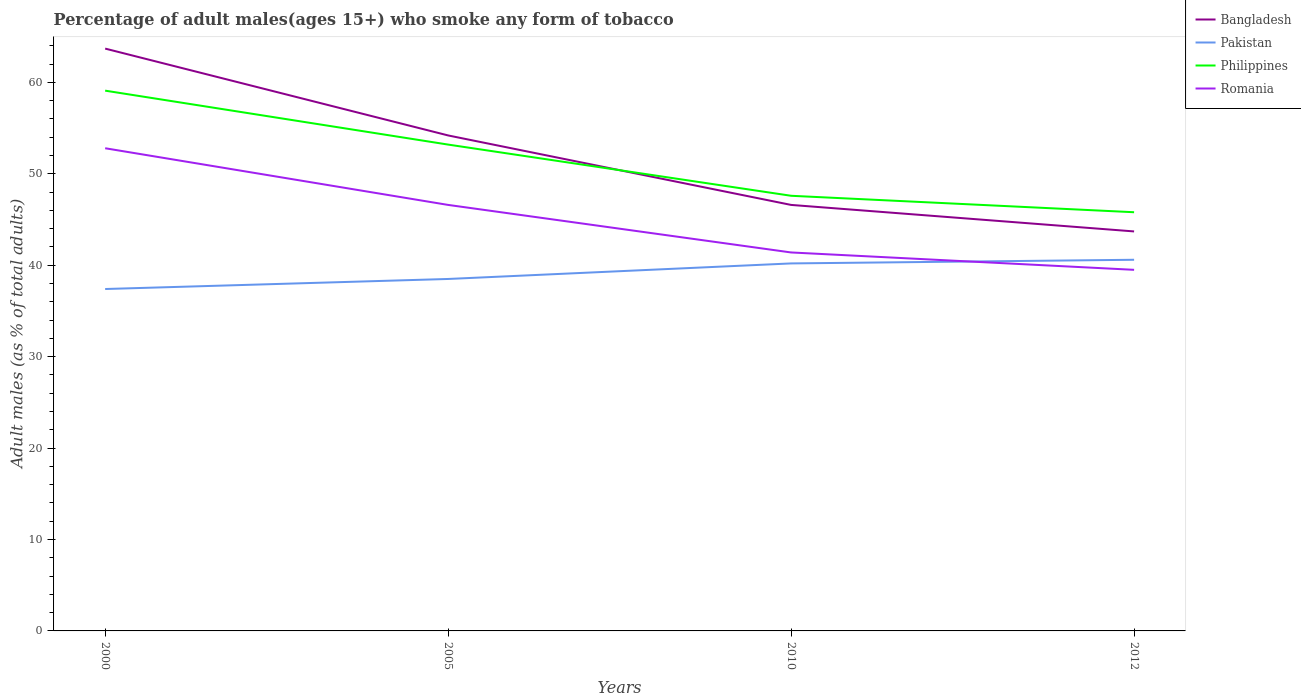Is the number of lines equal to the number of legend labels?
Your answer should be very brief. Yes. Across all years, what is the maximum percentage of adult males who smoke in Bangladesh?
Ensure brevity in your answer.  43.7. In which year was the percentage of adult males who smoke in Bangladesh maximum?
Your response must be concise. 2012. How many lines are there?
Your response must be concise. 4. What is the difference between two consecutive major ticks on the Y-axis?
Your answer should be compact. 10. Does the graph contain any zero values?
Your response must be concise. No. Does the graph contain grids?
Make the answer very short. No. How are the legend labels stacked?
Make the answer very short. Vertical. What is the title of the graph?
Make the answer very short. Percentage of adult males(ages 15+) who smoke any form of tobacco. Does "Chile" appear as one of the legend labels in the graph?
Offer a terse response. No. What is the label or title of the Y-axis?
Offer a terse response. Adult males (as % of total adults). What is the Adult males (as % of total adults) of Bangladesh in 2000?
Offer a very short reply. 63.7. What is the Adult males (as % of total adults) in Pakistan in 2000?
Give a very brief answer. 37.4. What is the Adult males (as % of total adults) in Philippines in 2000?
Your response must be concise. 59.1. What is the Adult males (as % of total adults) of Romania in 2000?
Your response must be concise. 52.8. What is the Adult males (as % of total adults) of Bangladesh in 2005?
Ensure brevity in your answer.  54.2. What is the Adult males (as % of total adults) in Pakistan in 2005?
Your response must be concise. 38.5. What is the Adult males (as % of total adults) of Philippines in 2005?
Provide a succinct answer. 53.2. What is the Adult males (as % of total adults) of Romania in 2005?
Your response must be concise. 46.6. What is the Adult males (as % of total adults) in Bangladesh in 2010?
Your response must be concise. 46.6. What is the Adult males (as % of total adults) in Pakistan in 2010?
Your response must be concise. 40.2. What is the Adult males (as % of total adults) in Philippines in 2010?
Your response must be concise. 47.6. What is the Adult males (as % of total adults) in Romania in 2010?
Provide a succinct answer. 41.4. What is the Adult males (as % of total adults) in Bangladesh in 2012?
Ensure brevity in your answer.  43.7. What is the Adult males (as % of total adults) of Pakistan in 2012?
Offer a very short reply. 40.6. What is the Adult males (as % of total adults) in Philippines in 2012?
Your answer should be compact. 45.8. What is the Adult males (as % of total adults) in Romania in 2012?
Your answer should be very brief. 39.5. Across all years, what is the maximum Adult males (as % of total adults) in Bangladesh?
Ensure brevity in your answer.  63.7. Across all years, what is the maximum Adult males (as % of total adults) of Pakistan?
Ensure brevity in your answer.  40.6. Across all years, what is the maximum Adult males (as % of total adults) in Philippines?
Ensure brevity in your answer.  59.1. Across all years, what is the maximum Adult males (as % of total adults) of Romania?
Your response must be concise. 52.8. Across all years, what is the minimum Adult males (as % of total adults) of Bangladesh?
Offer a very short reply. 43.7. Across all years, what is the minimum Adult males (as % of total adults) of Pakistan?
Your answer should be very brief. 37.4. Across all years, what is the minimum Adult males (as % of total adults) of Philippines?
Offer a very short reply. 45.8. Across all years, what is the minimum Adult males (as % of total adults) of Romania?
Give a very brief answer. 39.5. What is the total Adult males (as % of total adults) in Bangladesh in the graph?
Ensure brevity in your answer.  208.2. What is the total Adult males (as % of total adults) of Pakistan in the graph?
Ensure brevity in your answer.  156.7. What is the total Adult males (as % of total adults) in Philippines in the graph?
Your response must be concise. 205.7. What is the total Adult males (as % of total adults) of Romania in the graph?
Make the answer very short. 180.3. What is the difference between the Adult males (as % of total adults) of Pakistan in 2000 and that in 2005?
Your answer should be compact. -1.1. What is the difference between the Adult males (as % of total adults) of Philippines in 2000 and that in 2005?
Provide a short and direct response. 5.9. What is the difference between the Adult males (as % of total adults) of Romania in 2000 and that in 2005?
Make the answer very short. 6.2. What is the difference between the Adult males (as % of total adults) of Bangladesh in 2000 and that in 2010?
Provide a succinct answer. 17.1. What is the difference between the Adult males (as % of total adults) of Romania in 2000 and that in 2010?
Your answer should be very brief. 11.4. What is the difference between the Adult males (as % of total adults) in Bangladesh in 2000 and that in 2012?
Offer a terse response. 20. What is the difference between the Adult males (as % of total adults) in Pakistan in 2000 and that in 2012?
Provide a succinct answer. -3.2. What is the difference between the Adult males (as % of total adults) in Philippines in 2000 and that in 2012?
Ensure brevity in your answer.  13.3. What is the difference between the Adult males (as % of total adults) of Pakistan in 2005 and that in 2010?
Offer a very short reply. -1.7. What is the difference between the Adult males (as % of total adults) in Philippines in 2005 and that in 2010?
Offer a terse response. 5.6. What is the difference between the Adult males (as % of total adults) of Romania in 2005 and that in 2010?
Offer a very short reply. 5.2. What is the difference between the Adult males (as % of total adults) of Bangladesh in 2005 and that in 2012?
Keep it short and to the point. 10.5. What is the difference between the Adult males (as % of total adults) of Pakistan in 2005 and that in 2012?
Your response must be concise. -2.1. What is the difference between the Adult males (as % of total adults) in Pakistan in 2010 and that in 2012?
Your response must be concise. -0.4. What is the difference between the Adult males (as % of total adults) in Romania in 2010 and that in 2012?
Keep it short and to the point. 1.9. What is the difference between the Adult males (as % of total adults) of Bangladesh in 2000 and the Adult males (as % of total adults) of Pakistan in 2005?
Offer a very short reply. 25.2. What is the difference between the Adult males (as % of total adults) in Pakistan in 2000 and the Adult males (as % of total adults) in Philippines in 2005?
Keep it short and to the point. -15.8. What is the difference between the Adult males (as % of total adults) of Pakistan in 2000 and the Adult males (as % of total adults) of Romania in 2005?
Keep it short and to the point. -9.2. What is the difference between the Adult males (as % of total adults) of Bangladesh in 2000 and the Adult males (as % of total adults) of Romania in 2010?
Keep it short and to the point. 22.3. What is the difference between the Adult males (as % of total adults) in Pakistan in 2000 and the Adult males (as % of total adults) in Philippines in 2010?
Your response must be concise. -10.2. What is the difference between the Adult males (as % of total adults) of Bangladesh in 2000 and the Adult males (as % of total adults) of Pakistan in 2012?
Offer a very short reply. 23.1. What is the difference between the Adult males (as % of total adults) in Bangladesh in 2000 and the Adult males (as % of total adults) in Romania in 2012?
Make the answer very short. 24.2. What is the difference between the Adult males (as % of total adults) of Pakistan in 2000 and the Adult males (as % of total adults) of Philippines in 2012?
Provide a short and direct response. -8.4. What is the difference between the Adult males (as % of total adults) in Philippines in 2000 and the Adult males (as % of total adults) in Romania in 2012?
Give a very brief answer. 19.6. What is the difference between the Adult males (as % of total adults) in Philippines in 2005 and the Adult males (as % of total adults) in Romania in 2010?
Give a very brief answer. 11.8. What is the difference between the Adult males (as % of total adults) of Bangladesh in 2005 and the Adult males (as % of total adults) of Pakistan in 2012?
Provide a short and direct response. 13.6. What is the difference between the Adult males (as % of total adults) of Bangladesh in 2005 and the Adult males (as % of total adults) of Philippines in 2012?
Offer a terse response. 8.4. What is the difference between the Adult males (as % of total adults) in Pakistan in 2005 and the Adult males (as % of total adults) in Philippines in 2012?
Ensure brevity in your answer.  -7.3. What is the difference between the Adult males (as % of total adults) of Pakistan in 2005 and the Adult males (as % of total adults) of Romania in 2012?
Offer a terse response. -1. What is the difference between the Adult males (as % of total adults) in Philippines in 2005 and the Adult males (as % of total adults) in Romania in 2012?
Your response must be concise. 13.7. What is the difference between the Adult males (as % of total adults) of Bangladesh in 2010 and the Adult males (as % of total adults) of Pakistan in 2012?
Provide a succinct answer. 6. What is the difference between the Adult males (as % of total adults) of Bangladesh in 2010 and the Adult males (as % of total adults) of Philippines in 2012?
Your answer should be very brief. 0.8. What is the difference between the Adult males (as % of total adults) in Pakistan in 2010 and the Adult males (as % of total adults) in Philippines in 2012?
Provide a succinct answer. -5.6. What is the difference between the Adult males (as % of total adults) in Pakistan in 2010 and the Adult males (as % of total adults) in Romania in 2012?
Provide a succinct answer. 0.7. What is the difference between the Adult males (as % of total adults) in Philippines in 2010 and the Adult males (as % of total adults) in Romania in 2012?
Make the answer very short. 8.1. What is the average Adult males (as % of total adults) in Bangladesh per year?
Keep it short and to the point. 52.05. What is the average Adult males (as % of total adults) in Pakistan per year?
Ensure brevity in your answer.  39.17. What is the average Adult males (as % of total adults) in Philippines per year?
Make the answer very short. 51.42. What is the average Adult males (as % of total adults) in Romania per year?
Give a very brief answer. 45.08. In the year 2000, what is the difference between the Adult males (as % of total adults) of Bangladesh and Adult males (as % of total adults) of Pakistan?
Ensure brevity in your answer.  26.3. In the year 2000, what is the difference between the Adult males (as % of total adults) of Pakistan and Adult males (as % of total adults) of Philippines?
Your response must be concise. -21.7. In the year 2000, what is the difference between the Adult males (as % of total adults) in Pakistan and Adult males (as % of total adults) in Romania?
Make the answer very short. -15.4. In the year 2005, what is the difference between the Adult males (as % of total adults) of Bangladesh and Adult males (as % of total adults) of Pakistan?
Provide a short and direct response. 15.7. In the year 2005, what is the difference between the Adult males (as % of total adults) in Bangladesh and Adult males (as % of total adults) in Romania?
Give a very brief answer. 7.6. In the year 2005, what is the difference between the Adult males (as % of total adults) of Pakistan and Adult males (as % of total adults) of Philippines?
Provide a short and direct response. -14.7. In the year 2005, what is the difference between the Adult males (as % of total adults) in Philippines and Adult males (as % of total adults) in Romania?
Keep it short and to the point. 6.6. In the year 2010, what is the difference between the Adult males (as % of total adults) in Bangladesh and Adult males (as % of total adults) in Pakistan?
Your response must be concise. 6.4. In the year 2010, what is the difference between the Adult males (as % of total adults) in Bangladesh and Adult males (as % of total adults) in Romania?
Provide a succinct answer. 5.2. In the year 2010, what is the difference between the Adult males (as % of total adults) of Pakistan and Adult males (as % of total adults) of Philippines?
Offer a very short reply. -7.4. In the year 2012, what is the difference between the Adult males (as % of total adults) in Bangladesh and Adult males (as % of total adults) in Pakistan?
Keep it short and to the point. 3.1. What is the ratio of the Adult males (as % of total adults) of Bangladesh in 2000 to that in 2005?
Provide a short and direct response. 1.18. What is the ratio of the Adult males (as % of total adults) of Pakistan in 2000 to that in 2005?
Make the answer very short. 0.97. What is the ratio of the Adult males (as % of total adults) in Philippines in 2000 to that in 2005?
Your answer should be very brief. 1.11. What is the ratio of the Adult males (as % of total adults) of Romania in 2000 to that in 2005?
Your answer should be compact. 1.13. What is the ratio of the Adult males (as % of total adults) in Bangladesh in 2000 to that in 2010?
Provide a short and direct response. 1.37. What is the ratio of the Adult males (as % of total adults) of Pakistan in 2000 to that in 2010?
Offer a very short reply. 0.93. What is the ratio of the Adult males (as % of total adults) in Philippines in 2000 to that in 2010?
Your answer should be compact. 1.24. What is the ratio of the Adult males (as % of total adults) of Romania in 2000 to that in 2010?
Offer a terse response. 1.28. What is the ratio of the Adult males (as % of total adults) of Bangladesh in 2000 to that in 2012?
Your response must be concise. 1.46. What is the ratio of the Adult males (as % of total adults) in Pakistan in 2000 to that in 2012?
Provide a succinct answer. 0.92. What is the ratio of the Adult males (as % of total adults) of Philippines in 2000 to that in 2012?
Your answer should be very brief. 1.29. What is the ratio of the Adult males (as % of total adults) in Romania in 2000 to that in 2012?
Provide a short and direct response. 1.34. What is the ratio of the Adult males (as % of total adults) in Bangladesh in 2005 to that in 2010?
Ensure brevity in your answer.  1.16. What is the ratio of the Adult males (as % of total adults) of Pakistan in 2005 to that in 2010?
Your response must be concise. 0.96. What is the ratio of the Adult males (as % of total adults) in Philippines in 2005 to that in 2010?
Offer a very short reply. 1.12. What is the ratio of the Adult males (as % of total adults) in Romania in 2005 to that in 2010?
Offer a terse response. 1.13. What is the ratio of the Adult males (as % of total adults) of Bangladesh in 2005 to that in 2012?
Your answer should be compact. 1.24. What is the ratio of the Adult males (as % of total adults) of Pakistan in 2005 to that in 2012?
Give a very brief answer. 0.95. What is the ratio of the Adult males (as % of total adults) in Philippines in 2005 to that in 2012?
Offer a very short reply. 1.16. What is the ratio of the Adult males (as % of total adults) in Romania in 2005 to that in 2012?
Make the answer very short. 1.18. What is the ratio of the Adult males (as % of total adults) in Bangladesh in 2010 to that in 2012?
Ensure brevity in your answer.  1.07. What is the ratio of the Adult males (as % of total adults) in Pakistan in 2010 to that in 2012?
Provide a short and direct response. 0.99. What is the ratio of the Adult males (as % of total adults) in Philippines in 2010 to that in 2012?
Provide a succinct answer. 1.04. What is the ratio of the Adult males (as % of total adults) of Romania in 2010 to that in 2012?
Your answer should be compact. 1.05. What is the difference between the highest and the second highest Adult males (as % of total adults) of Bangladesh?
Offer a very short reply. 9.5. What is the difference between the highest and the lowest Adult males (as % of total adults) of Pakistan?
Provide a short and direct response. 3.2. What is the difference between the highest and the lowest Adult males (as % of total adults) of Romania?
Ensure brevity in your answer.  13.3. 